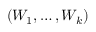<formula> <loc_0><loc_0><loc_500><loc_500>( W _ { 1 } , \dots , W _ { k } )</formula> 